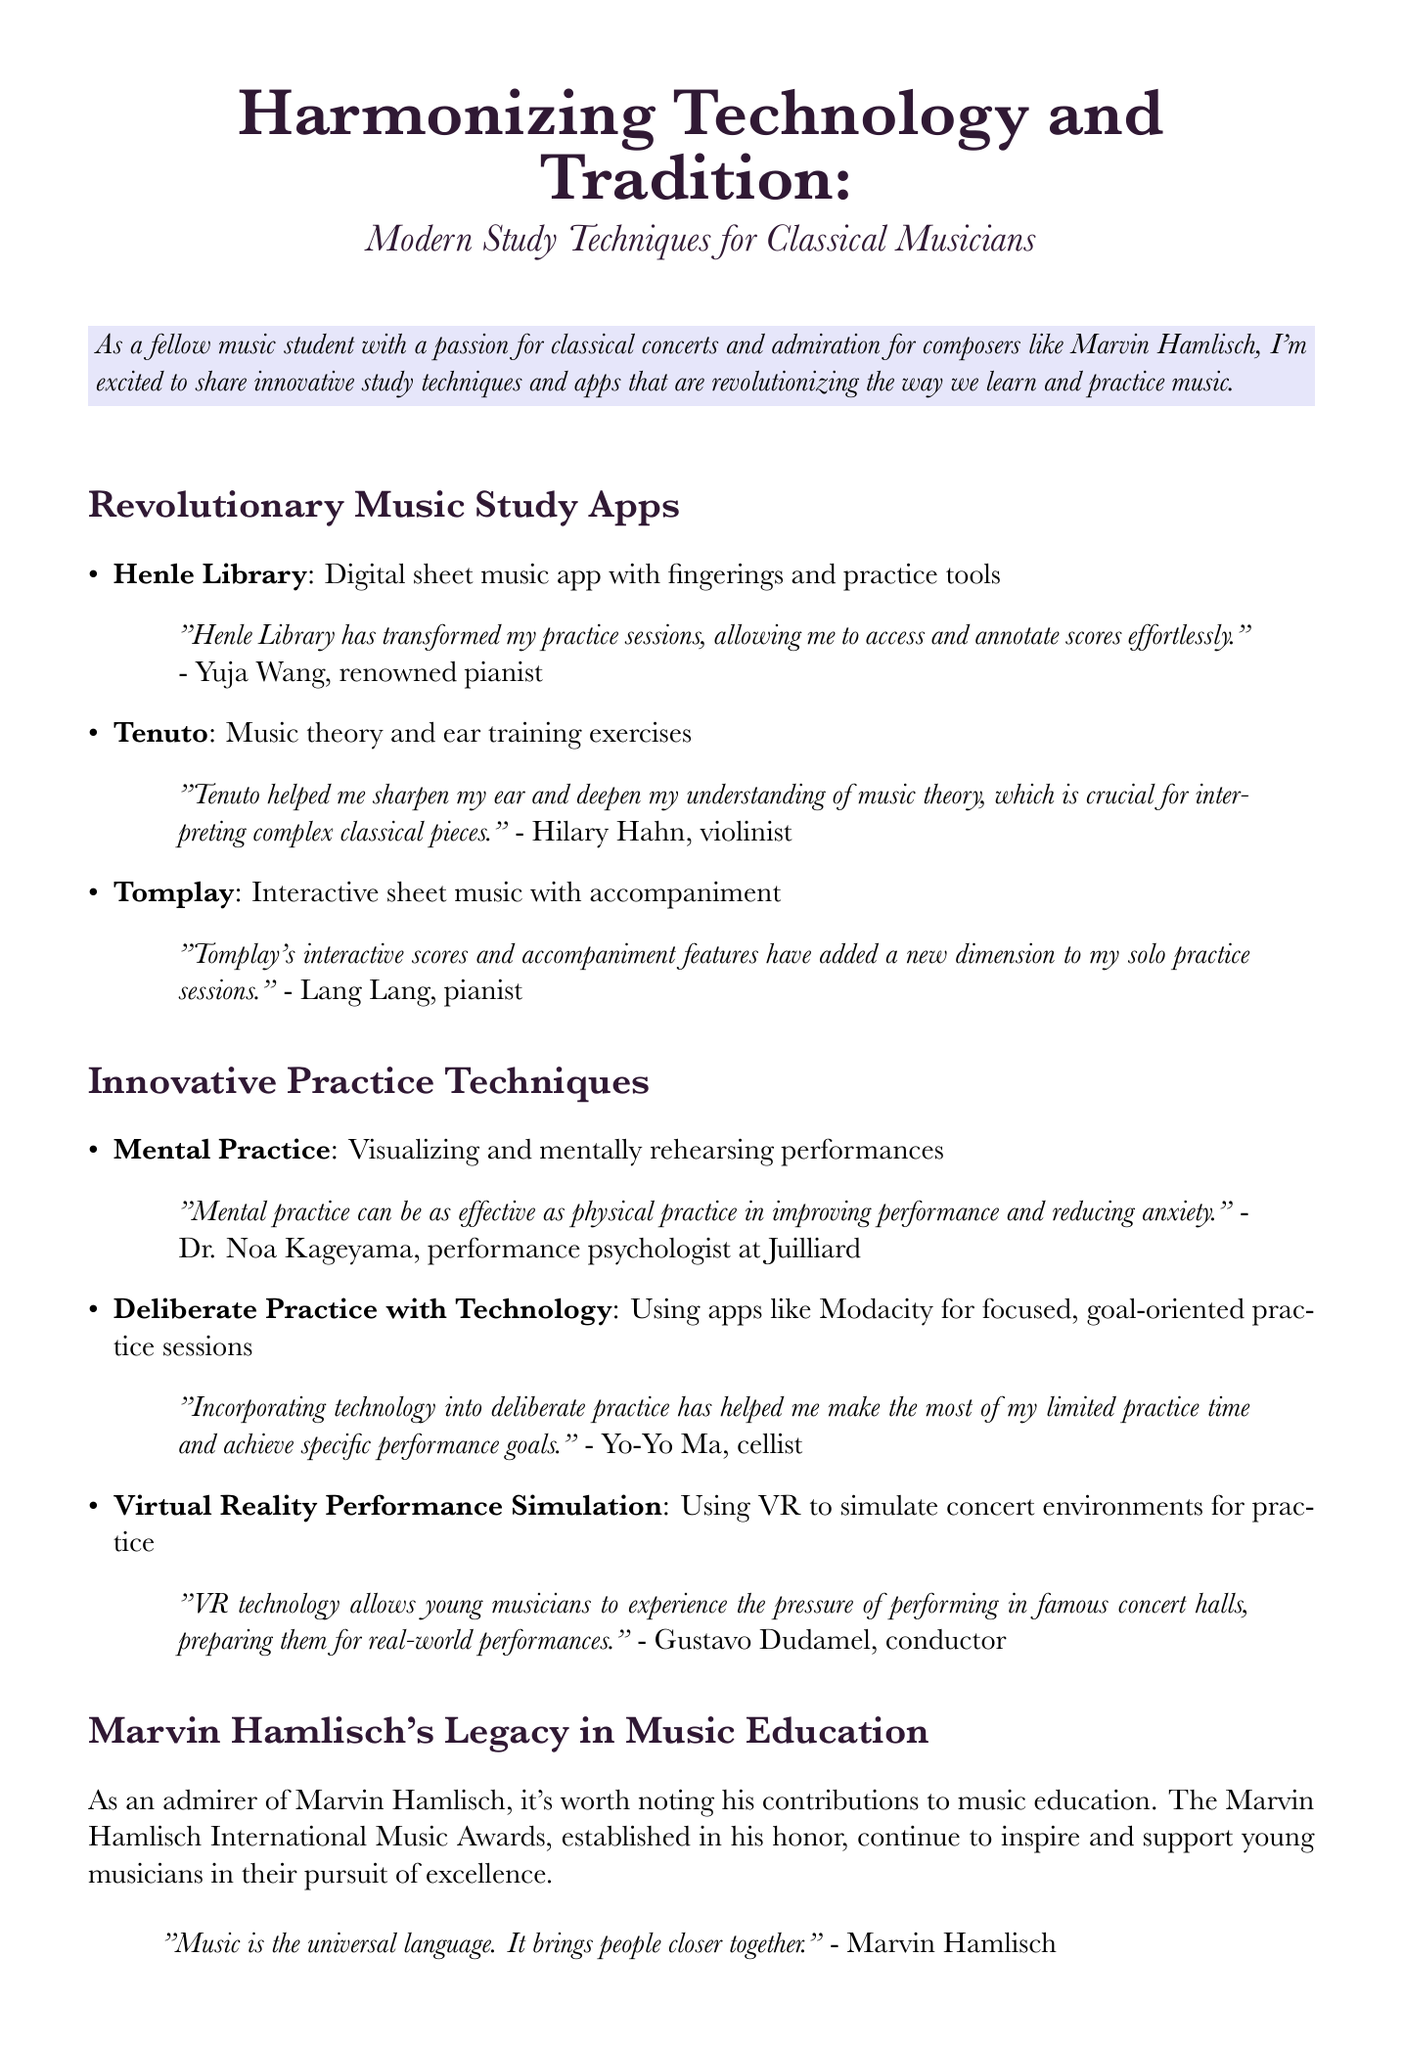What is the title of the newsletter? The title of the newsletter is stated at the top of the document.
Answer: Harmonizing Technology and Tradition: Modern Study Techniques for Classical Musicians Who is the user of the Henle Library app? This information is provided within the testimonials in the document.
Answer: Yuja Wang What type of exercises does the Tenuto app provide? The description of the app specifies the type of exercises it offers.
Answer: Music theory and ear training exercises What technique involves visualizing performances? The document lists various innovative techniques for music practice.
Answer: Mental Practice Who is quoted saying, "Music is the universal language?" This quote is attributed to a notable figure in the document.
Answer: Marvin Hamlisch Which app is referred to for interactive sheet music? The document lists several apps and specifies features unique to each one.
Answer: Tomplay What is Dr. Noa Kageyama's profession? The document mentions Dr. Noa Kageyama's expertise in relation to a practice technique.
Answer: Performance psychologist What musical legacy is mentioned in the newsletter? The document highlights contributions to music education related to a specific individual.
Answer: Marvin Hamlisch's Legacy in Music Education How does Yo-Yo Ma utilize technology in practice? The user testimonial shares his approach to using technology.
Answer: Deliberate Practice with Technology 